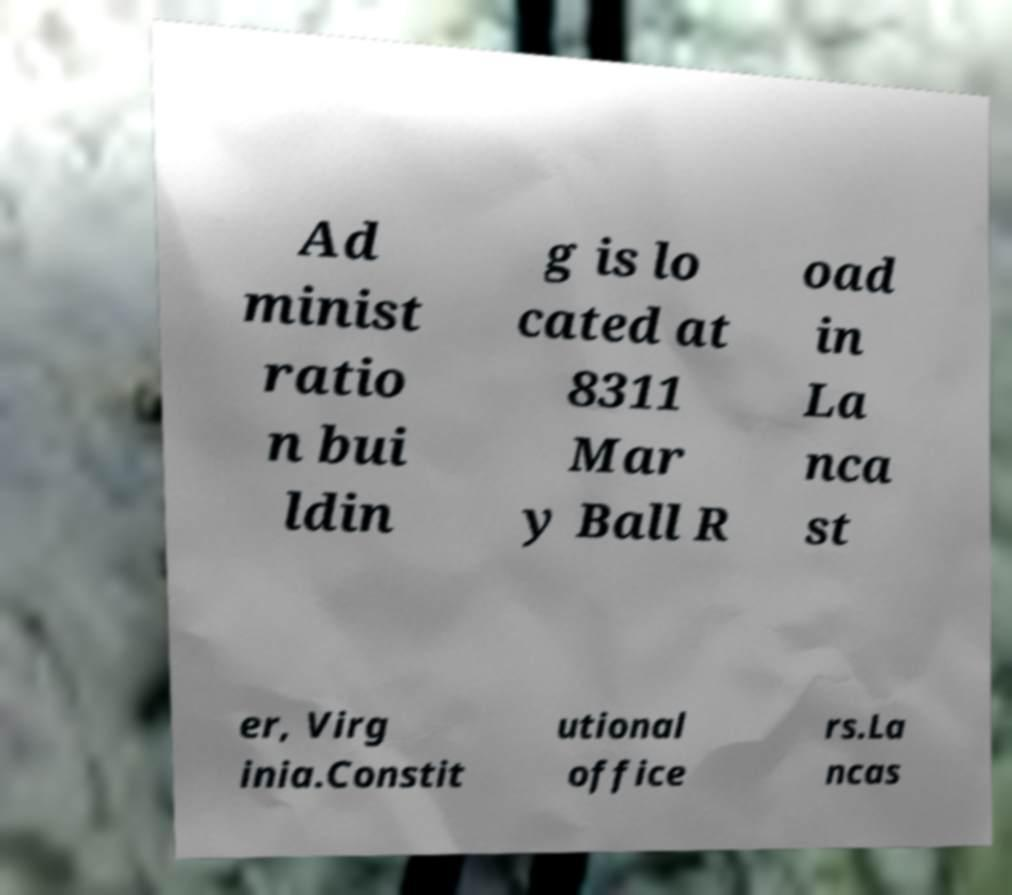Could you extract and type out the text from this image? Ad minist ratio n bui ldin g is lo cated at 8311 Mar y Ball R oad in La nca st er, Virg inia.Constit utional office rs.La ncas 